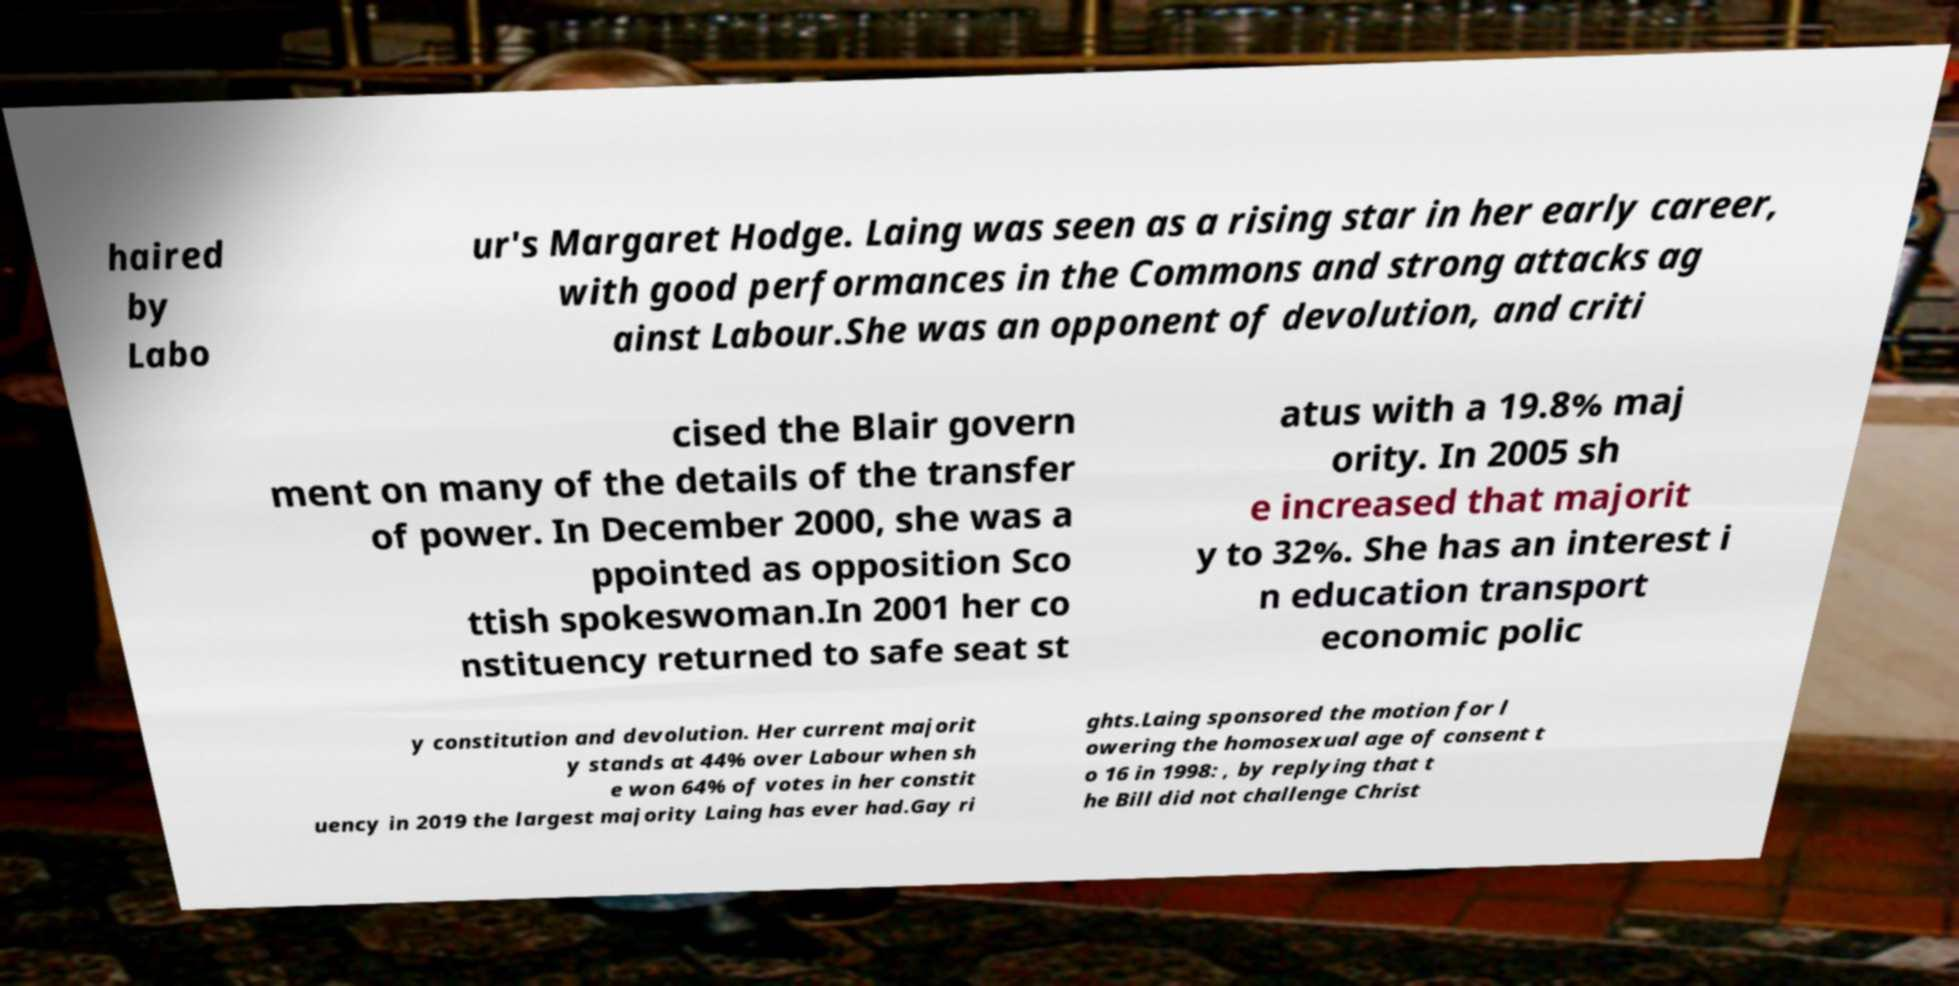Could you assist in decoding the text presented in this image and type it out clearly? haired by Labo ur's Margaret Hodge. Laing was seen as a rising star in her early career, with good performances in the Commons and strong attacks ag ainst Labour.She was an opponent of devolution, and criti cised the Blair govern ment on many of the details of the transfer of power. In December 2000, she was a ppointed as opposition Sco ttish spokeswoman.In 2001 her co nstituency returned to safe seat st atus with a 19.8% maj ority. In 2005 sh e increased that majorit y to 32%. She has an interest i n education transport economic polic y constitution and devolution. Her current majorit y stands at 44% over Labour when sh e won 64% of votes in her constit uency in 2019 the largest majority Laing has ever had.Gay ri ghts.Laing sponsored the motion for l owering the homosexual age of consent t o 16 in 1998: , by replying that t he Bill did not challenge Christ 